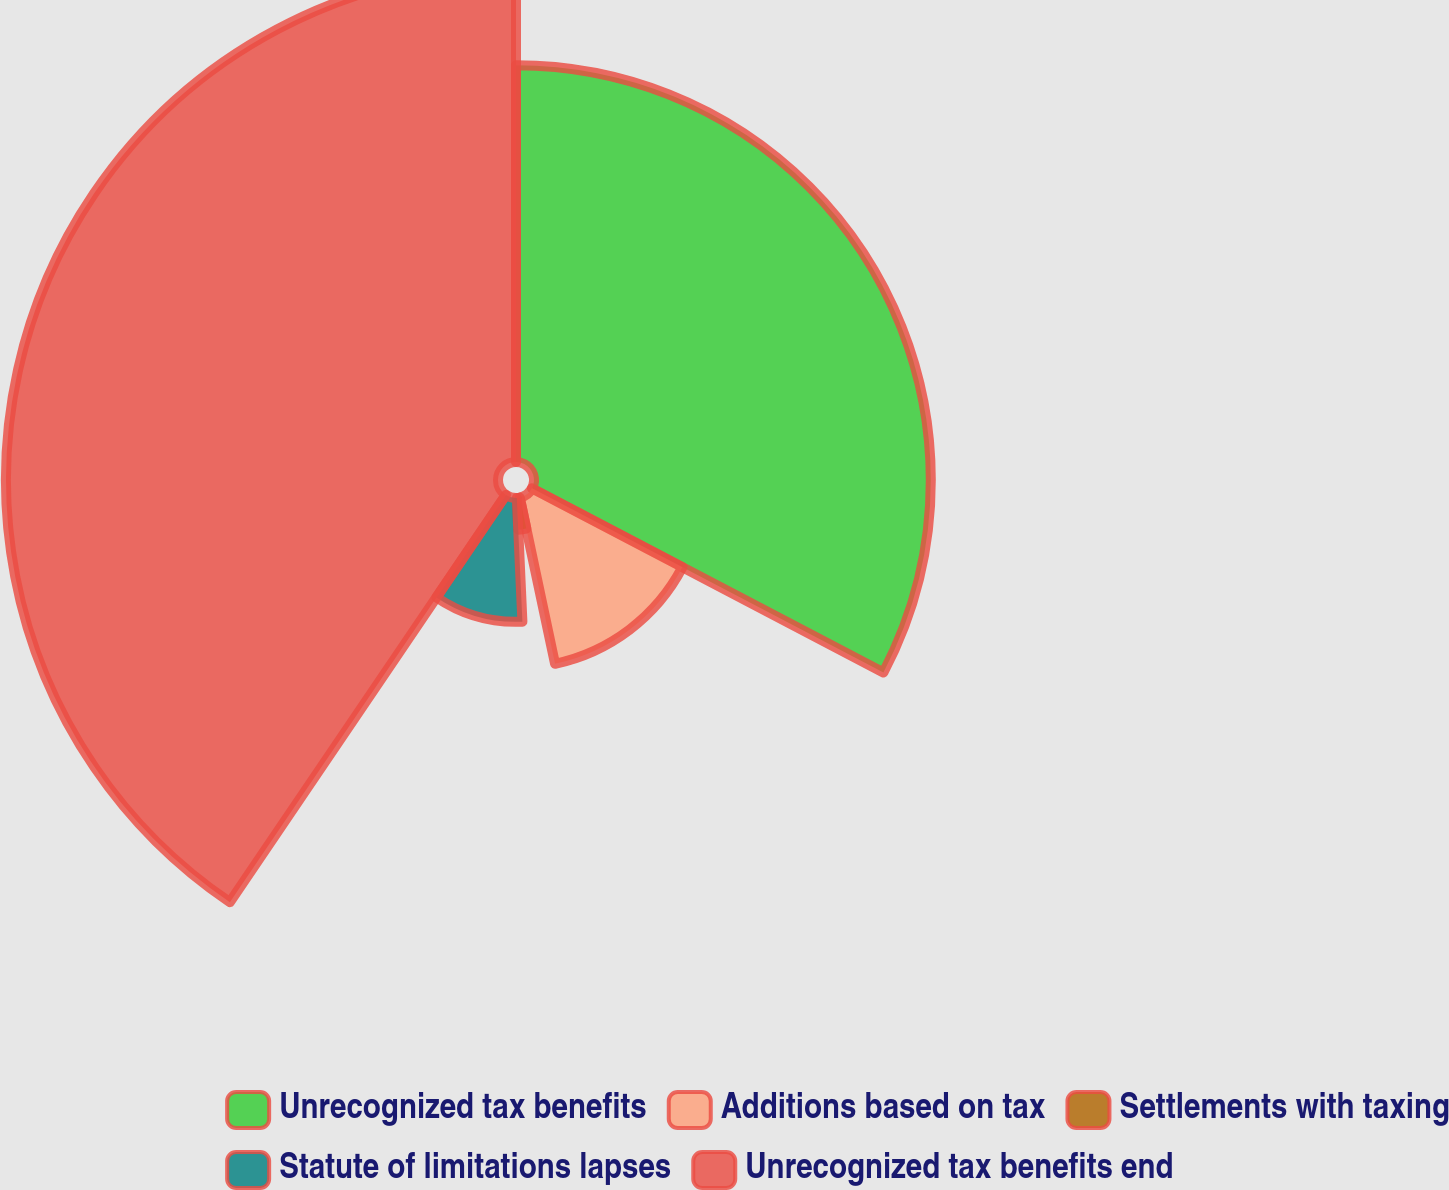Convert chart. <chart><loc_0><loc_0><loc_500><loc_500><pie_chart><fcel>Unrecognized tax benefits<fcel>Additions based on tax<fcel>Settlements with taxing<fcel>Statute of limitations lapses<fcel>Unrecognized tax benefits end<nl><fcel>32.68%<fcel>13.99%<fcel>2.61%<fcel>10.2%<fcel>40.52%<nl></chart> 